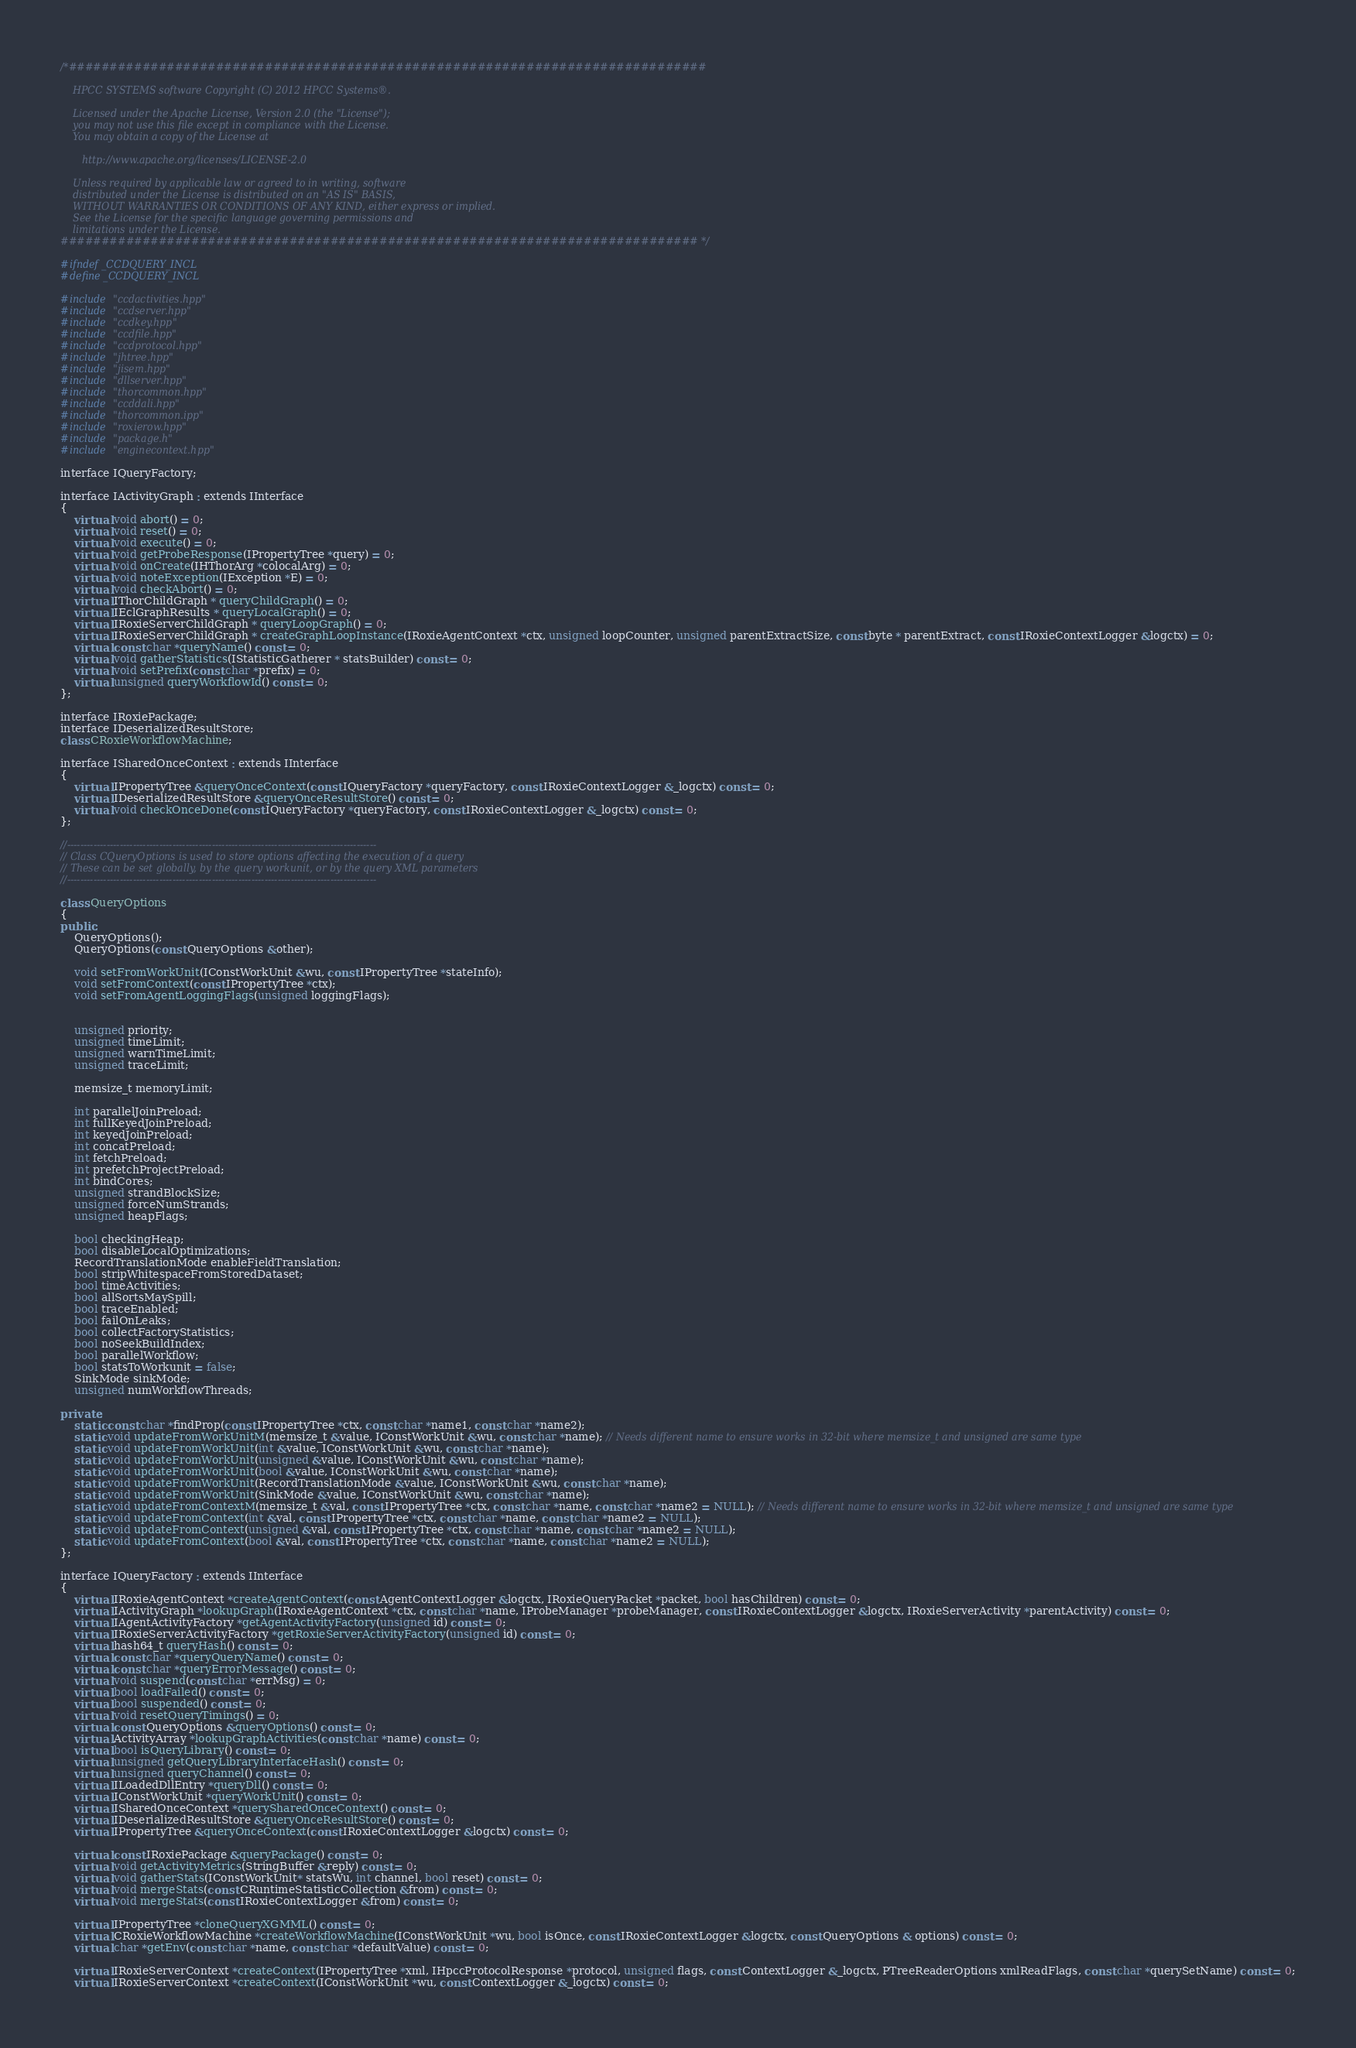<code> <loc_0><loc_0><loc_500><loc_500><_C++_>/*##############################################################################

    HPCC SYSTEMS software Copyright (C) 2012 HPCC Systems®.

    Licensed under the Apache License, Version 2.0 (the "License");
    you may not use this file except in compliance with the License.
    You may obtain a copy of the License at

       http://www.apache.org/licenses/LICENSE-2.0

    Unless required by applicable law or agreed to in writing, software
    distributed under the License is distributed on an "AS IS" BASIS,
    WITHOUT WARRANTIES OR CONDITIONS OF ANY KIND, either express or implied.
    See the License for the specific language governing permissions and
    limitations under the License.
############################################################################## */

#ifndef _CCDQUERY_INCL
#define _CCDQUERY_INCL

#include "ccdactivities.hpp"
#include "ccdserver.hpp"
#include "ccdkey.hpp"
#include "ccdfile.hpp"
#include "ccdprotocol.hpp"
#include "jhtree.hpp"
#include "jisem.hpp"
#include "dllserver.hpp"
#include "thorcommon.hpp"
#include "ccddali.hpp"
#include "thorcommon.ipp"
#include "roxierow.hpp"
#include "package.h"
#include "enginecontext.hpp"

interface IQueryFactory;

interface IActivityGraph : extends IInterface
{
    virtual void abort() = 0;
    virtual void reset() = 0;
    virtual void execute() = 0;
    virtual void getProbeResponse(IPropertyTree *query) = 0;
    virtual void onCreate(IHThorArg *colocalArg) = 0;
    virtual void noteException(IException *E) = 0;
    virtual void checkAbort() = 0;
    virtual IThorChildGraph * queryChildGraph() = 0;
    virtual IEclGraphResults * queryLocalGraph() = 0;
    virtual IRoxieServerChildGraph * queryLoopGraph() = 0;
    virtual IRoxieServerChildGraph * createGraphLoopInstance(IRoxieAgentContext *ctx, unsigned loopCounter, unsigned parentExtractSize, const byte * parentExtract, const IRoxieContextLogger &logctx) = 0;
    virtual const char *queryName() const = 0;
    virtual void gatherStatistics(IStatisticGatherer * statsBuilder) const = 0;
    virtual void setPrefix(const char *prefix) = 0;
    virtual unsigned queryWorkflowId() const = 0;
};

interface IRoxiePackage;
interface IDeserializedResultStore;
class CRoxieWorkflowMachine;

interface ISharedOnceContext : extends IInterface
{
    virtual IPropertyTree &queryOnceContext(const IQueryFactory *queryFactory, const IRoxieContextLogger &_logctx) const = 0;
    virtual IDeserializedResultStore &queryOnceResultStore() const = 0;
    virtual void checkOnceDone(const IQueryFactory *queryFactory, const IRoxieContextLogger &_logctx) const = 0;
};

//----------------------------------------------------------------------------------------------
// Class CQueryOptions is used to store options affecting the execution of a query
// These can be set globally, by the query workunit, or by the query XML parameters
//----------------------------------------------------------------------------------------------

class QueryOptions
{
public:
    QueryOptions();
    QueryOptions(const QueryOptions &other);

    void setFromWorkUnit(IConstWorkUnit &wu, const IPropertyTree *stateInfo);
    void setFromContext(const IPropertyTree *ctx);
    void setFromAgentLoggingFlags(unsigned loggingFlags);


    unsigned priority;
    unsigned timeLimit;
    unsigned warnTimeLimit;
    unsigned traceLimit;

    memsize_t memoryLimit;

    int parallelJoinPreload;
    int fullKeyedJoinPreload;
    int keyedJoinPreload;
    int concatPreload;
    int fetchPreload;
    int prefetchProjectPreload;
    int bindCores;
    unsigned strandBlockSize;
    unsigned forceNumStrands;
    unsigned heapFlags;

    bool checkingHeap;
    bool disableLocalOptimizations;
    RecordTranslationMode enableFieldTranslation;
    bool stripWhitespaceFromStoredDataset;
    bool timeActivities;
    bool allSortsMaySpill;
    bool traceEnabled;
    bool failOnLeaks;
    bool collectFactoryStatistics;
    bool noSeekBuildIndex;
    bool parallelWorkflow;
    bool statsToWorkunit = false;
    SinkMode sinkMode;
    unsigned numWorkflowThreads;

private:
    static const char *findProp(const IPropertyTree *ctx, const char *name1, const char *name2);
    static void updateFromWorkUnitM(memsize_t &value, IConstWorkUnit &wu, const char *name); // Needs different name to ensure works in 32-bit where memsize_t and unsigned are same type
    static void updateFromWorkUnit(int &value, IConstWorkUnit &wu, const char *name);
    static void updateFromWorkUnit(unsigned &value, IConstWorkUnit &wu, const char *name);
    static void updateFromWorkUnit(bool &value, IConstWorkUnit &wu, const char *name);
    static void updateFromWorkUnit(RecordTranslationMode &value, IConstWorkUnit &wu, const char *name);
    static void updateFromWorkUnit(SinkMode &value, IConstWorkUnit &wu, const char *name);
    static void updateFromContextM(memsize_t &val, const IPropertyTree *ctx, const char *name, const char *name2 = NULL); // Needs different name to ensure works in 32-bit where memsize_t and unsigned are same type
    static void updateFromContext(int &val, const IPropertyTree *ctx, const char *name, const char *name2 = NULL);
    static void updateFromContext(unsigned &val, const IPropertyTree *ctx, const char *name, const char *name2 = NULL);
    static void updateFromContext(bool &val, const IPropertyTree *ctx, const char *name, const char *name2 = NULL);
};

interface IQueryFactory : extends IInterface
{
    virtual IRoxieAgentContext *createAgentContext(const AgentContextLogger &logctx, IRoxieQueryPacket *packet, bool hasChildren) const = 0;
    virtual IActivityGraph *lookupGraph(IRoxieAgentContext *ctx, const char *name, IProbeManager *probeManager, const IRoxieContextLogger &logctx, IRoxieServerActivity *parentActivity) const = 0;
    virtual IAgentActivityFactory *getAgentActivityFactory(unsigned id) const = 0;
    virtual IRoxieServerActivityFactory *getRoxieServerActivityFactory(unsigned id) const = 0;
    virtual hash64_t queryHash() const = 0;
    virtual const char *queryQueryName() const = 0;
    virtual const char *queryErrorMessage() const = 0;
    virtual void suspend(const char *errMsg) = 0;
    virtual bool loadFailed() const = 0;
    virtual bool suspended() const = 0;
    virtual void resetQueryTimings() = 0;
    virtual const QueryOptions &queryOptions() const = 0;
    virtual ActivityArray *lookupGraphActivities(const char *name) const = 0;
    virtual bool isQueryLibrary() const = 0;
    virtual unsigned getQueryLibraryInterfaceHash() const = 0;
    virtual unsigned queryChannel() const = 0;
    virtual ILoadedDllEntry *queryDll() const = 0;
    virtual IConstWorkUnit *queryWorkUnit() const = 0;
    virtual ISharedOnceContext *querySharedOnceContext() const = 0;
    virtual IDeserializedResultStore &queryOnceResultStore() const = 0;
    virtual IPropertyTree &queryOnceContext(const IRoxieContextLogger &logctx) const = 0;

    virtual const IRoxiePackage &queryPackage() const = 0;
    virtual void getActivityMetrics(StringBuffer &reply) const = 0;
    virtual void gatherStats(IConstWorkUnit* statsWu, int channel, bool reset) const = 0;
    virtual void mergeStats(const CRuntimeStatisticCollection &from) const = 0;
    virtual void mergeStats(const IRoxieContextLogger &from) const = 0;

    virtual IPropertyTree *cloneQueryXGMML() const = 0;
    virtual CRoxieWorkflowMachine *createWorkflowMachine(IConstWorkUnit *wu, bool isOnce, const IRoxieContextLogger &logctx, const QueryOptions & options) const = 0;
    virtual char *getEnv(const char *name, const char *defaultValue) const = 0;

    virtual IRoxieServerContext *createContext(IPropertyTree *xml, IHpccProtocolResponse *protocol, unsigned flags, const ContextLogger &_logctx, PTreeReaderOptions xmlReadFlags, const char *querySetName) const = 0;
    virtual IRoxieServerContext *createContext(IConstWorkUnit *wu, const ContextLogger &_logctx) const = 0;</code> 